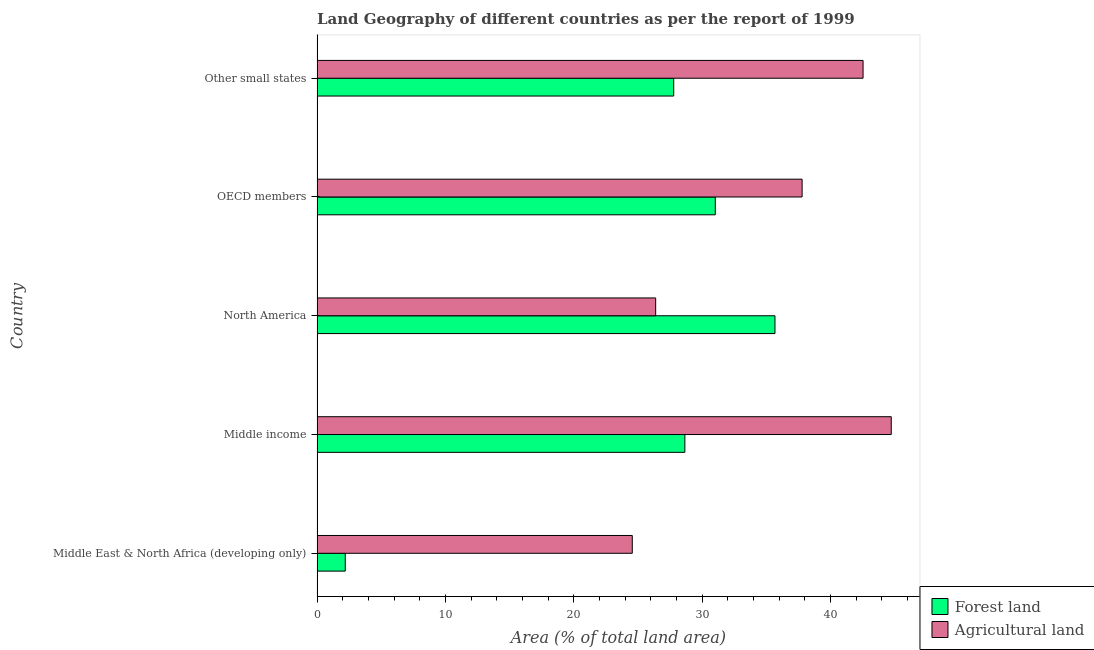How many different coloured bars are there?
Your answer should be compact. 2. How many groups of bars are there?
Your answer should be compact. 5. Are the number of bars per tick equal to the number of legend labels?
Provide a succinct answer. Yes. Are the number of bars on each tick of the Y-axis equal?
Ensure brevity in your answer.  Yes. How many bars are there on the 3rd tick from the top?
Offer a very short reply. 2. What is the label of the 2nd group of bars from the top?
Make the answer very short. OECD members. What is the percentage of land area under agriculture in Middle East & North Africa (developing only)?
Provide a short and direct response. 24.56. Across all countries, what is the maximum percentage of land area under agriculture?
Provide a short and direct response. 44.74. Across all countries, what is the minimum percentage of land area under agriculture?
Your answer should be very brief. 24.56. In which country was the percentage of land area under forests maximum?
Provide a short and direct response. North America. In which country was the percentage of land area under forests minimum?
Provide a short and direct response. Middle East & North Africa (developing only). What is the total percentage of land area under forests in the graph?
Keep it short and to the point. 125.36. What is the difference between the percentage of land area under forests in Middle East & North Africa (developing only) and that in North America?
Your answer should be compact. -33.48. What is the difference between the percentage of land area under agriculture in North America and the percentage of land area under forests in Middle East & North Africa (developing only)?
Provide a short and direct response. 24.19. What is the average percentage of land area under forests per country?
Provide a short and direct response. 25.07. What is the difference between the percentage of land area under agriculture and percentage of land area under forests in Middle income?
Ensure brevity in your answer.  16.08. In how many countries, is the percentage of land area under forests greater than 28 %?
Your answer should be compact. 3. What is the ratio of the percentage of land area under forests in Middle East & North Africa (developing only) to that in Middle income?
Offer a very short reply. 0.08. Is the percentage of land area under agriculture in Middle East & North Africa (developing only) less than that in OECD members?
Offer a very short reply. Yes. Is the difference between the percentage of land area under agriculture in OECD members and Other small states greater than the difference between the percentage of land area under forests in OECD members and Other small states?
Offer a very short reply. No. What is the difference between the highest and the second highest percentage of land area under agriculture?
Provide a succinct answer. 2.2. What is the difference between the highest and the lowest percentage of land area under agriculture?
Provide a short and direct response. 20.18. Is the sum of the percentage of land area under agriculture in OECD members and Other small states greater than the maximum percentage of land area under forests across all countries?
Your answer should be very brief. Yes. What does the 2nd bar from the top in Other small states represents?
Make the answer very short. Forest land. What does the 1st bar from the bottom in Middle East & North Africa (developing only) represents?
Your response must be concise. Forest land. How many bars are there?
Make the answer very short. 10. Are the values on the major ticks of X-axis written in scientific E-notation?
Make the answer very short. No. Does the graph contain any zero values?
Ensure brevity in your answer.  No. Does the graph contain grids?
Make the answer very short. No. Where does the legend appear in the graph?
Your response must be concise. Bottom right. How are the legend labels stacked?
Your answer should be very brief. Vertical. What is the title of the graph?
Your answer should be very brief. Land Geography of different countries as per the report of 1999. Does "2012 US$" appear as one of the legend labels in the graph?
Offer a very short reply. No. What is the label or title of the X-axis?
Your response must be concise. Area (% of total land area). What is the label or title of the Y-axis?
Your response must be concise. Country. What is the Area (% of total land area) in Forest land in Middle East & North Africa (developing only)?
Keep it short and to the point. 2.2. What is the Area (% of total land area) of Agricultural land in Middle East & North Africa (developing only)?
Provide a succinct answer. 24.56. What is the Area (% of total land area) in Forest land in Middle income?
Provide a short and direct response. 28.66. What is the Area (% of total land area) in Agricultural land in Middle income?
Keep it short and to the point. 44.74. What is the Area (% of total land area) in Forest land in North America?
Give a very brief answer. 35.68. What is the Area (% of total land area) in Agricultural land in North America?
Give a very brief answer. 26.39. What is the Area (% of total land area) in Forest land in OECD members?
Provide a succinct answer. 31.03. What is the Area (% of total land area) in Agricultural land in OECD members?
Provide a succinct answer. 37.8. What is the Area (% of total land area) of Forest land in Other small states?
Offer a terse response. 27.79. What is the Area (% of total land area) of Agricultural land in Other small states?
Provide a succinct answer. 42.55. Across all countries, what is the maximum Area (% of total land area) in Forest land?
Make the answer very short. 35.68. Across all countries, what is the maximum Area (% of total land area) of Agricultural land?
Give a very brief answer. 44.74. Across all countries, what is the minimum Area (% of total land area) in Forest land?
Offer a terse response. 2.2. Across all countries, what is the minimum Area (% of total land area) of Agricultural land?
Ensure brevity in your answer.  24.56. What is the total Area (% of total land area) in Forest land in the graph?
Your response must be concise. 125.36. What is the total Area (% of total land area) in Agricultural land in the graph?
Your response must be concise. 176.03. What is the difference between the Area (% of total land area) in Forest land in Middle East & North Africa (developing only) and that in Middle income?
Your answer should be compact. -26.46. What is the difference between the Area (% of total land area) of Agricultural land in Middle East & North Africa (developing only) and that in Middle income?
Your answer should be very brief. -20.18. What is the difference between the Area (% of total land area) of Forest land in Middle East & North Africa (developing only) and that in North America?
Your answer should be compact. -33.48. What is the difference between the Area (% of total land area) of Agricultural land in Middle East & North Africa (developing only) and that in North America?
Give a very brief answer. -1.82. What is the difference between the Area (% of total land area) of Forest land in Middle East & North Africa (developing only) and that in OECD members?
Your response must be concise. -28.83. What is the difference between the Area (% of total land area) in Agricultural land in Middle East & North Africa (developing only) and that in OECD members?
Keep it short and to the point. -13.23. What is the difference between the Area (% of total land area) of Forest land in Middle East & North Africa (developing only) and that in Other small states?
Ensure brevity in your answer.  -25.59. What is the difference between the Area (% of total land area) in Agricultural land in Middle East & North Africa (developing only) and that in Other small states?
Your answer should be compact. -17.98. What is the difference between the Area (% of total land area) in Forest land in Middle income and that in North America?
Ensure brevity in your answer.  -7.02. What is the difference between the Area (% of total land area) of Agricultural land in Middle income and that in North America?
Ensure brevity in your answer.  18.36. What is the difference between the Area (% of total land area) in Forest land in Middle income and that in OECD members?
Offer a very short reply. -2.37. What is the difference between the Area (% of total land area) of Agricultural land in Middle income and that in OECD members?
Your answer should be very brief. 6.95. What is the difference between the Area (% of total land area) in Forest land in Middle income and that in Other small states?
Offer a very short reply. 0.87. What is the difference between the Area (% of total land area) in Agricultural land in Middle income and that in Other small states?
Give a very brief answer. 2.2. What is the difference between the Area (% of total land area) of Forest land in North America and that in OECD members?
Your answer should be very brief. 4.65. What is the difference between the Area (% of total land area) of Agricultural land in North America and that in OECD members?
Provide a short and direct response. -11.41. What is the difference between the Area (% of total land area) of Forest land in North America and that in Other small states?
Your answer should be very brief. 7.89. What is the difference between the Area (% of total land area) in Agricultural land in North America and that in Other small states?
Provide a succinct answer. -16.16. What is the difference between the Area (% of total land area) in Forest land in OECD members and that in Other small states?
Offer a very short reply. 3.24. What is the difference between the Area (% of total land area) of Agricultural land in OECD members and that in Other small states?
Make the answer very short. -4.75. What is the difference between the Area (% of total land area) of Forest land in Middle East & North Africa (developing only) and the Area (% of total land area) of Agricultural land in Middle income?
Offer a terse response. -42.54. What is the difference between the Area (% of total land area) in Forest land in Middle East & North Africa (developing only) and the Area (% of total land area) in Agricultural land in North America?
Give a very brief answer. -24.19. What is the difference between the Area (% of total land area) of Forest land in Middle East & North Africa (developing only) and the Area (% of total land area) of Agricultural land in OECD members?
Keep it short and to the point. -35.6. What is the difference between the Area (% of total land area) of Forest land in Middle East & North Africa (developing only) and the Area (% of total land area) of Agricultural land in Other small states?
Provide a short and direct response. -40.35. What is the difference between the Area (% of total land area) in Forest land in Middle income and the Area (% of total land area) in Agricultural land in North America?
Provide a succinct answer. 2.27. What is the difference between the Area (% of total land area) in Forest land in Middle income and the Area (% of total land area) in Agricultural land in OECD members?
Ensure brevity in your answer.  -9.14. What is the difference between the Area (% of total land area) in Forest land in Middle income and the Area (% of total land area) in Agricultural land in Other small states?
Give a very brief answer. -13.89. What is the difference between the Area (% of total land area) of Forest land in North America and the Area (% of total land area) of Agricultural land in OECD members?
Ensure brevity in your answer.  -2.12. What is the difference between the Area (% of total land area) of Forest land in North America and the Area (% of total land area) of Agricultural land in Other small states?
Your answer should be compact. -6.86. What is the difference between the Area (% of total land area) in Forest land in OECD members and the Area (% of total land area) in Agricultural land in Other small states?
Your response must be concise. -11.51. What is the average Area (% of total land area) in Forest land per country?
Provide a short and direct response. 25.07. What is the average Area (% of total land area) of Agricultural land per country?
Make the answer very short. 35.21. What is the difference between the Area (% of total land area) of Forest land and Area (% of total land area) of Agricultural land in Middle East & North Africa (developing only)?
Your answer should be compact. -22.36. What is the difference between the Area (% of total land area) in Forest land and Area (% of total land area) in Agricultural land in Middle income?
Provide a succinct answer. -16.08. What is the difference between the Area (% of total land area) in Forest land and Area (% of total land area) in Agricultural land in North America?
Offer a very short reply. 9.3. What is the difference between the Area (% of total land area) in Forest land and Area (% of total land area) in Agricultural land in OECD members?
Your answer should be very brief. -6.77. What is the difference between the Area (% of total land area) in Forest land and Area (% of total land area) in Agricultural land in Other small states?
Your answer should be very brief. -14.75. What is the ratio of the Area (% of total land area) of Forest land in Middle East & North Africa (developing only) to that in Middle income?
Your answer should be compact. 0.08. What is the ratio of the Area (% of total land area) in Agricultural land in Middle East & North Africa (developing only) to that in Middle income?
Offer a terse response. 0.55. What is the ratio of the Area (% of total land area) of Forest land in Middle East & North Africa (developing only) to that in North America?
Ensure brevity in your answer.  0.06. What is the ratio of the Area (% of total land area) in Agricultural land in Middle East & North Africa (developing only) to that in North America?
Give a very brief answer. 0.93. What is the ratio of the Area (% of total land area) in Forest land in Middle East & North Africa (developing only) to that in OECD members?
Your answer should be very brief. 0.07. What is the ratio of the Area (% of total land area) in Agricultural land in Middle East & North Africa (developing only) to that in OECD members?
Offer a very short reply. 0.65. What is the ratio of the Area (% of total land area) of Forest land in Middle East & North Africa (developing only) to that in Other small states?
Make the answer very short. 0.08. What is the ratio of the Area (% of total land area) in Agricultural land in Middle East & North Africa (developing only) to that in Other small states?
Provide a short and direct response. 0.58. What is the ratio of the Area (% of total land area) of Forest land in Middle income to that in North America?
Your answer should be compact. 0.8. What is the ratio of the Area (% of total land area) of Agricultural land in Middle income to that in North America?
Ensure brevity in your answer.  1.7. What is the ratio of the Area (% of total land area) of Forest land in Middle income to that in OECD members?
Ensure brevity in your answer.  0.92. What is the ratio of the Area (% of total land area) in Agricultural land in Middle income to that in OECD members?
Your answer should be compact. 1.18. What is the ratio of the Area (% of total land area) in Forest land in Middle income to that in Other small states?
Your answer should be compact. 1.03. What is the ratio of the Area (% of total land area) in Agricultural land in Middle income to that in Other small states?
Your answer should be compact. 1.05. What is the ratio of the Area (% of total land area) of Forest land in North America to that in OECD members?
Provide a short and direct response. 1.15. What is the ratio of the Area (% of total land area) of Agricultural land in North America to that in OECD members?
Offer a terse response. 0.7. What is the ratio of the Area (% of total land area) in Forest land in North America to that in Other small states?
Provide a succinct answer. 1.28. What is the ratio of the Area (% of total land area) of Agricultural land in North America to that in Other small states?
Ensure brevity in your answer.  0.62. What is the ratio of the Area (% of total land area) of Forest land in OECD members to that in Other small states?
Your response must be concise. 1.12. What is the ratio of the Area (% of total land area) of Agricultural land in OECD members to that in Other small states?
Your answer should be compact. 0.89. What is the difference between the highest and the second highest Area (% of total land area) of Forest land?
Offer a very short reply. 4.65. What is the difference between the highest and the second highest Area (% of total land area) in Agricultural land?
Offer a very short reply. 2.2. What is the difference between the highest and the lowest Area (% of total land area) of Forest land?
Your answer should be compact. 33.48. What is the difference between the highest and the lowest Area (% of total land area) of Agricultural land?
Your answer should be very brief. 20.18. 